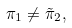Convert formula to latex. <formula><loc_0><loc_0><loc_500><loc_500>\pi _ { 1 } \neq \tilde { \pi } _ { 2 } ,</formula> 